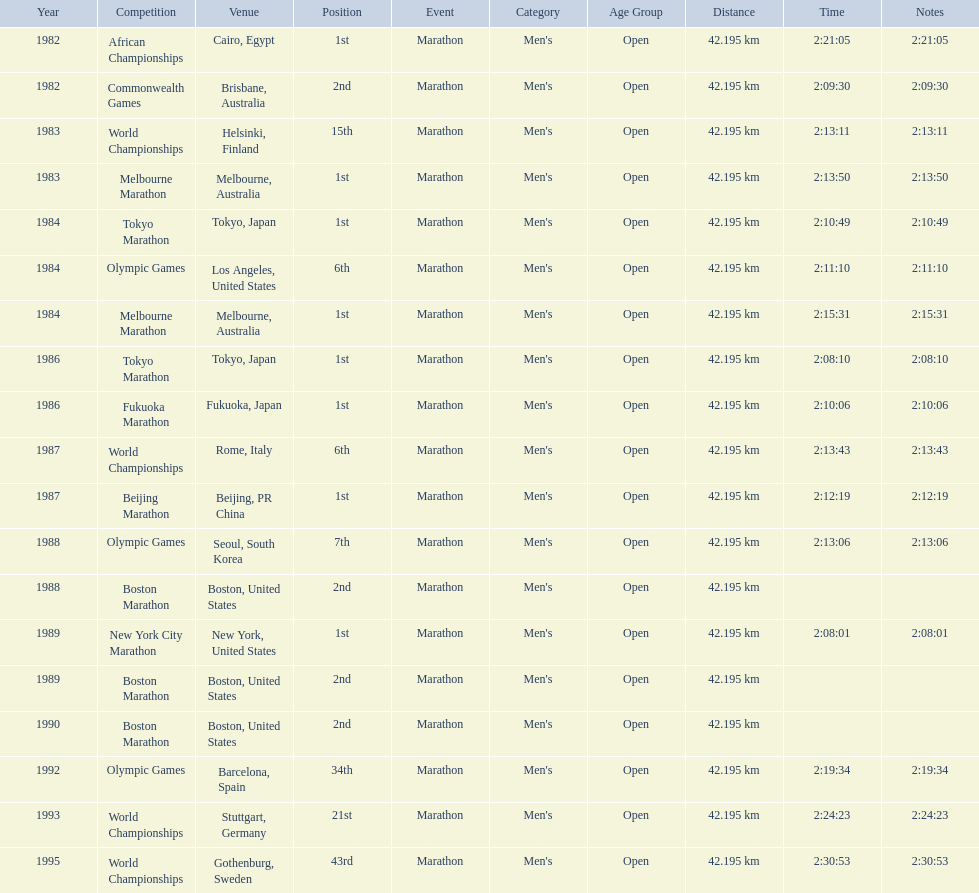What are all of the juma ikangaa competitions? African Championships, Commonwealth Games, World Championships, Melbourne Marathon, Tokyo Marathon, Olympic Games, Melbourne Marathon, Tokyo Marathon, Fukuoka Marathon, World Championships, Beijing Marathon, Olympic Games, Boston Marathon, New York City Marathon, Boston Marathon, Boston Marathon, Olympic Games, World Championships, World Championships. Which of these competitions did not take place in the united states? African Championships, Commonwealth Games, World Championships, Melbourne Marathon, Tokyo Marathon, Melbourne Marathon, Tokyo Marathon, Fukuoka Marathon, World Championships, Beijing Marathon, Olympic Games, Olympic Games, World Championships, World Championships. Out of these, which of them took place in asia? Tokyo Marathon, Tokyo Marathon, Fukuoka Marathon, Beijing Marathon, Olympic Games. Which of the remaining competitions took place in china? Beijing Marathon. 